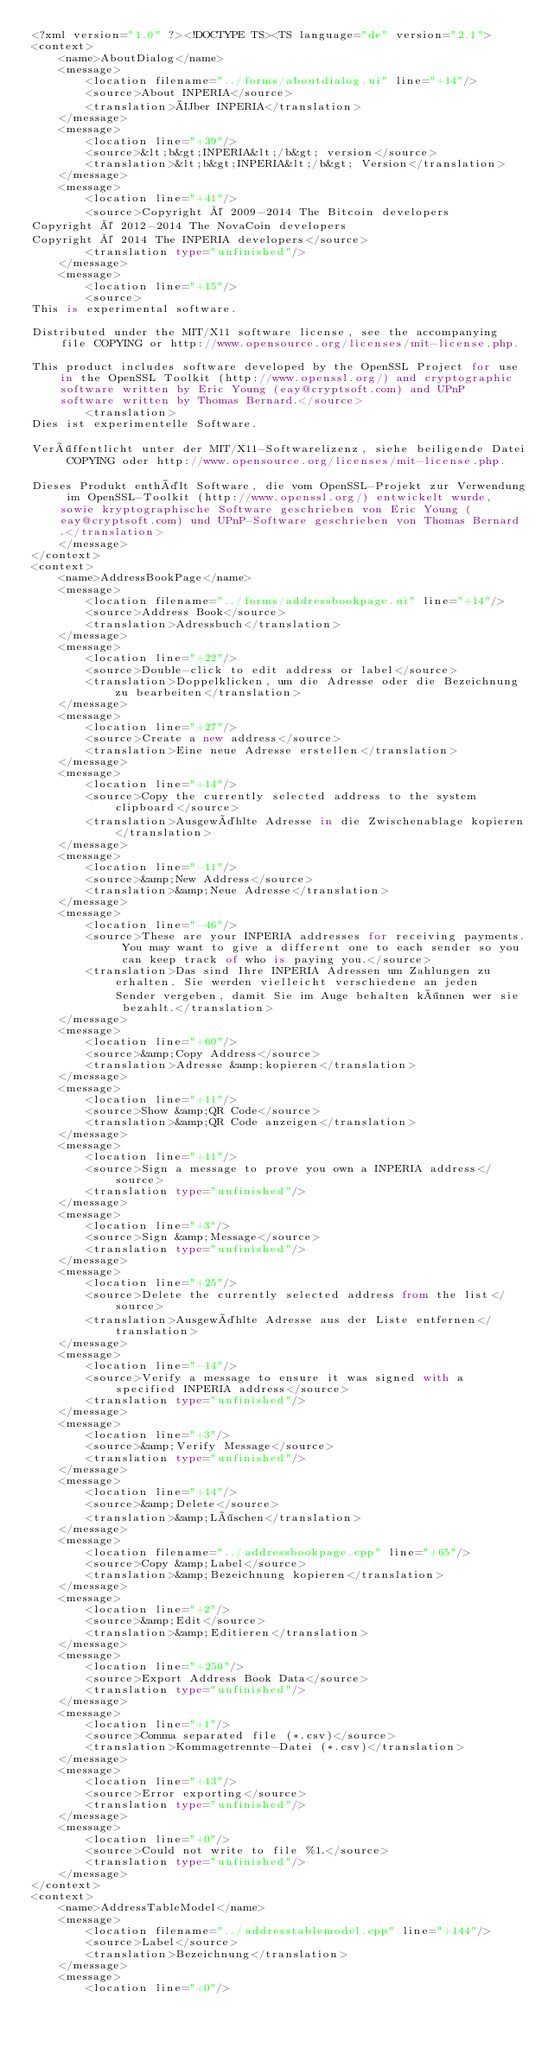<code> <loc_0><loc_0><loc_500><loc_500><_TypeScript_><?xml version="1.0" ?><!DOCTYPE TS><TS language="de" version="2.1">
<context>
    <name>AboutDialog</name>
    <message>
        <location filename="../forms/aboutdialog.ui" line="+14"/>
        <source>About INPERIA</source>
        <translation>Über INPERIA</translation>
    </message>
    <message>
        <location line="+39"/>
        <source>&lt;b&gt;INPERIA&lt;/b&gt; version</source>
        <translation>&lt;b&gt;INPERIA&lt;/b&gt; Version</translation>
    </message>
    <message>
        <location line="+41"/>
        <source>Copyright © 2009-2014 The Bitcoin developers
Copyright © 2012-2014 The NovaCoin developers
Copyright © 2014 The INPERIA developers</source>
        <translation type="unfinished"/>
    </message>
    <message>
        <location line="+15"/>
        <source>
This is experimental software.

Distributed under the MIT/X11 software license, see the accompanying file COPYING or http://www.opensource.org/licenses/mit-license.php.

This product includes software developed by the OpenSSL Project for use in the OpenSSL Toolkit (http://www.openssl.org/) and cryptographic software written by Eric Young (eay@cryptsoft.com) and UPnP software written by Thomas Bernard.</source>
        <translation>
Dies ist experimentelle Software.

Veröffentlicht unter der MIT/X11-Softwarelizenz, siehe beiligende Datei COPYING oder http://www.opensource.org/licenses/mit-license.php.

Dieses Produkt enthält Software, die vom OpenSSL-Projekt zur Verwendung im OpenSSL-Toolkit (http://www.openssl.org/) entwickelt wurde, sowie kryptographische Software geschrieben von Eric Young (eay@cryptsoft.com) und UPnP-Software geschrieben von Thomas Bernard.</translation>
    </message>
</context>
<context>
    <name>AddressBookPage</name>
    <message>
        <location filename="../forms/addressbookpage.ui" line="+14"/>
        <source>Address Book</source>
        <translation>Adressbuch</translation>
    </message>
    <message>
        <location line="+22"/>
        <source>Double-click to edit address or label</source>
        <translation>Doppelklicken, um die Adresse oder die Bezeichnung zu bearbeiten</translation>
    </message>
    <message>
        <location line="+27"/>
        <source>Create a new address</source>
        <translation>Eine neue Adresse erstellen</translation>
    </message>
    <message>
        <location line="+14"/>
        <source>Copy the currently selected address to the system clipboard</source>
        <translation>Ausgewählte Adresse in die Zwischenablage kopieren</translation>
    </message>
    <message>
        <location line="-11"/>
        <source>&amp;New Address</source>
        <translation>&amp;Neue Adresse</translation>
    </message>
    <message>
        <location line="-46"/>
        <source>These are your INPERIA addresses for receiving payments. You may want to give a different one to each sender so you can keep track of who is paying you.</source>
        <translation>Das sind Ihre INPERIA Adressen um Zahlungen zu erhalten. Sie werden vielleicht verschiedene an jeden Sender vergeben, damit Sie im Auge behalten können wer sie bezahlt.</translation>
    </message>
    <message>
        <location line="+60"/>
        <source>&amp;Copy Address</source>
        <translation>Adresse &amp;kopieren</translation>
    </message>
    <message>
        <location line="+11"/>
        <source>Show &amp;QR Code</source>
        <translation>&amp;QR Code anzeigen</translation>
    </message>
    <message>
        <location line="+11"/>
        <source>Sign a message to prove you own a INPERIA address</source>
        <translation type="unfinished"/>
    </message>
    <message>
        <location line="+3"/>
        <source>Sign &amp;Message</source>
        <translation type="unfinished"/>
    </message>
    <message>
        <location line="+25"/>
        <source>Delete the currently selected address from the list</source>
        <translation>Ausgewählte Adresse aus der Liste entfernen</translation>
    </message>
    <message>
        <location line="-14"/>
        <source>Verify a message to ensure it was signed with a specified INPERIA address</source>
        <translation type="unfinished"/>
    </message>
    <message>
        <location line="+3"/>
        <source>&amp;Verify Message</source>
        <translation type="unfinished"/>
    </message>
    <message>
        <location line="+14"/>
        <source>&amp;Delete</source>
        <translation>&amp;Löschen</translation>
    </message>
    <message>
        <location filename="../addressbookpage.cpp" line="+65"/>
        <source>Copy &amp;Label</source>
        <translation>&amp;Bezeichnung kopieren</translation>
    </message>
    <message>
        <location line="+2"/>
        <source>&amp;Edit</source>
        <translation>&amp;Editieren</translation>
    </message>
    <message>
        <location line="+250"/>
        <source>Export Address Book Data</source>
        <translation type="unfinished"/>
    </message>
    <message>
        <location line="+1"/>
        <source>Comma separated file (*.csv)</source>
        <translation>Kommagetrennte-Datei (*.csv)</translation>
    </message>
    <message>
        <location line="+13"/>
        <source>Error exporting</source>
        <translation type="unfinished"/>
    </message>
    <message>
        <location line="+0"/>
        <source>Could not write to file %1.</source>
        <translation type="unfinished"/>
    </message>
</context>
<context>
    <name>AddressTableModel</name>
    <message>
        <location filename="../addresstablemodel.cpp" line="+144"/>
        <source>Label</source>
        <translation>Bezeichnung</translation>
    </message>
    <message>
        <location line="+0"/></code> 